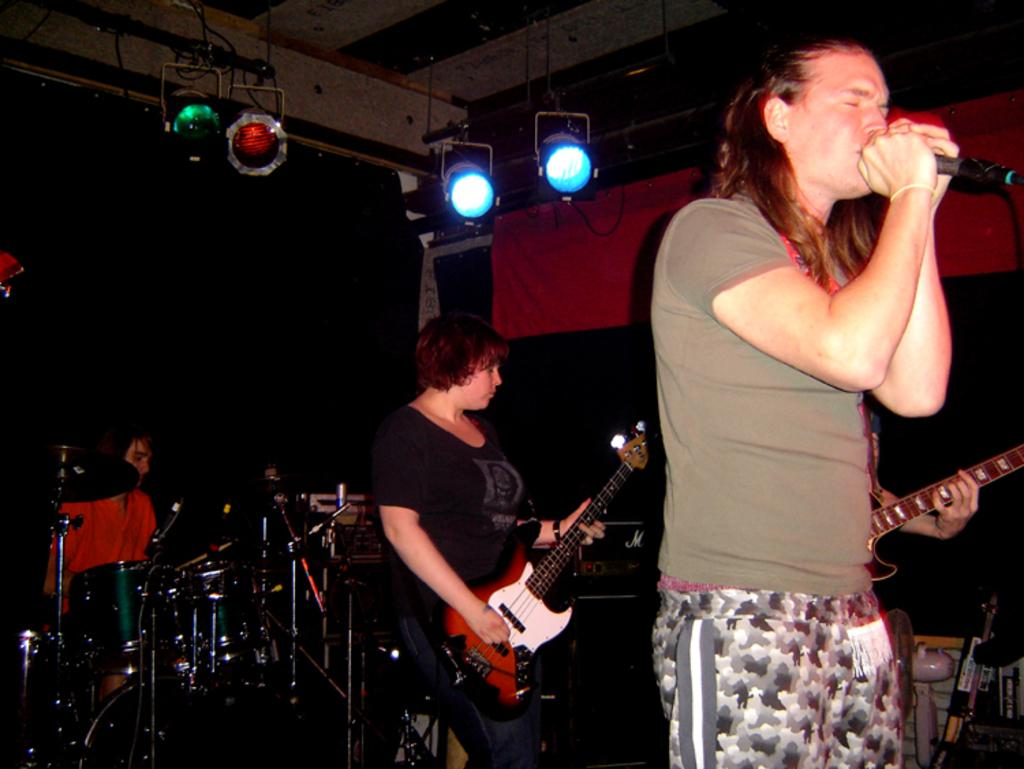What is the man in the image holding? The man is holding a microphone. What are the other people in the image doing? There is a person playing a guitar and another person playing drums in the image. What might the man with the microphone be doing? The man with the microphone might be singing or speaking into it. What is the price of the jar on the table in the image? There is no jar present in the image, so it is not possible to determine its price. 